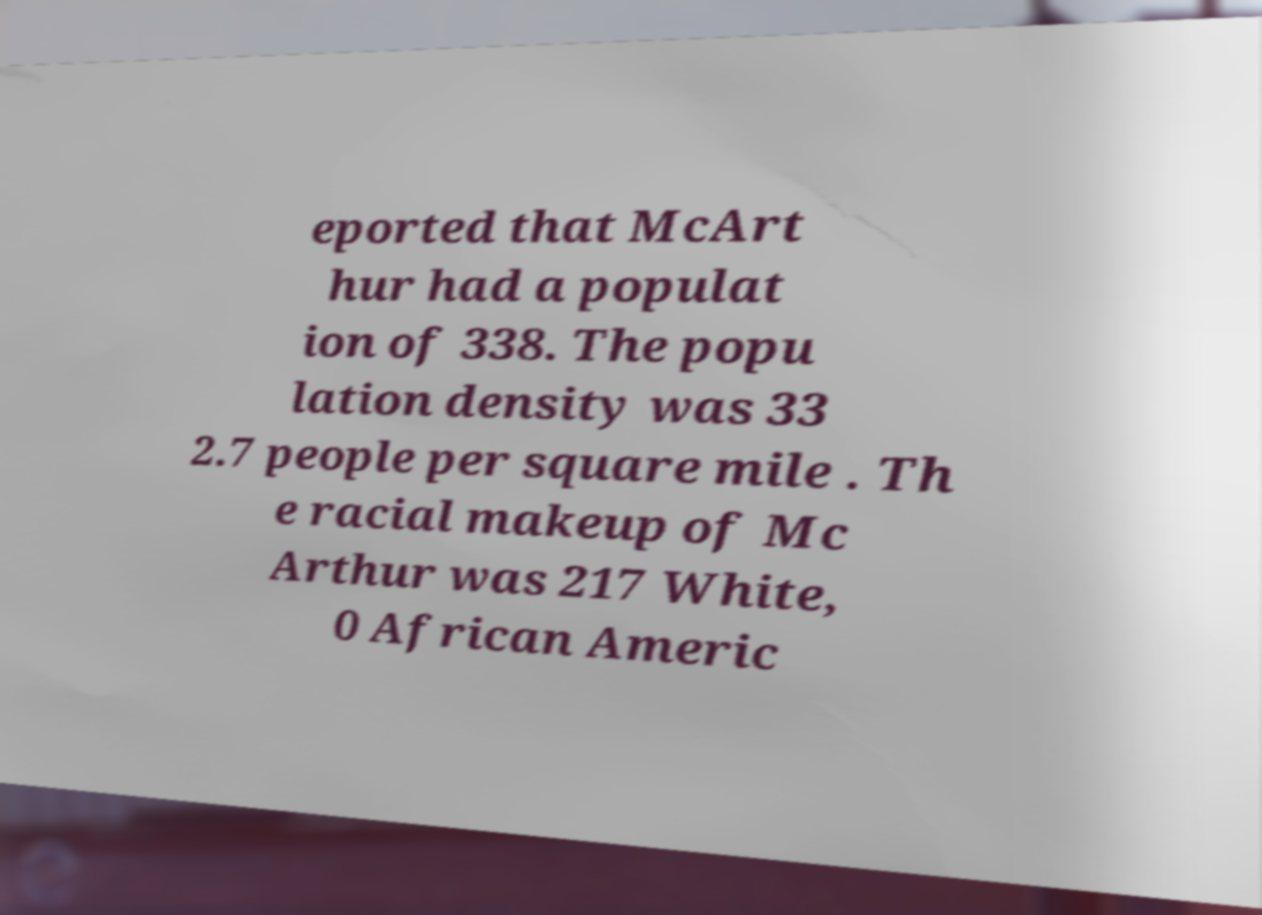Please identify and transcribe the text found in this image. eported that McArt hur had a populat ion of 338. The popu lation density was 33 2.7 people per square mile . Th e racial makeup of Mc Arthur was 217 White, 0 African Americ 